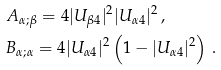<formula> <loc_0><loc_0><loc_500><loc_500>& A _ { \alpha ; \beta } = 4 | U _ { \beta 4 } | ^ { 2 } | U _ { \alpha 4 } | ^ { 2 } \, , \\ & B _ { \alpha ; \alpha } = 4 | U _ { \alpha 4 } | ^ { 2 } \left ( 1 - | U _ { \alpha 4 } | ^ { 2 } \right ) \, .</formula> 